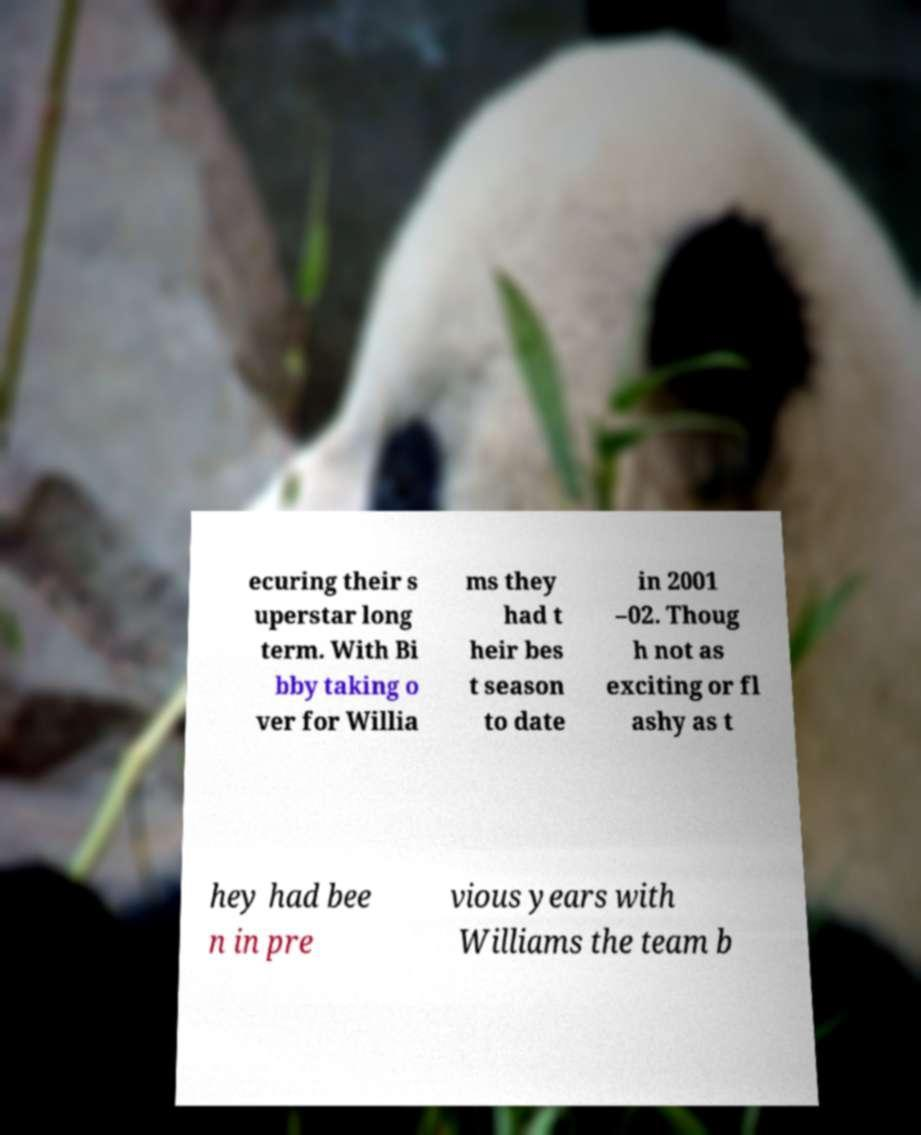Please identify and transcribe the text found in this image. ecuring their s uperstar long term. With Bi bby taking o ver for Willia ms they had t heir bes t season to date in 2001 –02. Thoug h not as exciting or fl ashy as t hey had bee n in pre vious years with Williams the team b 